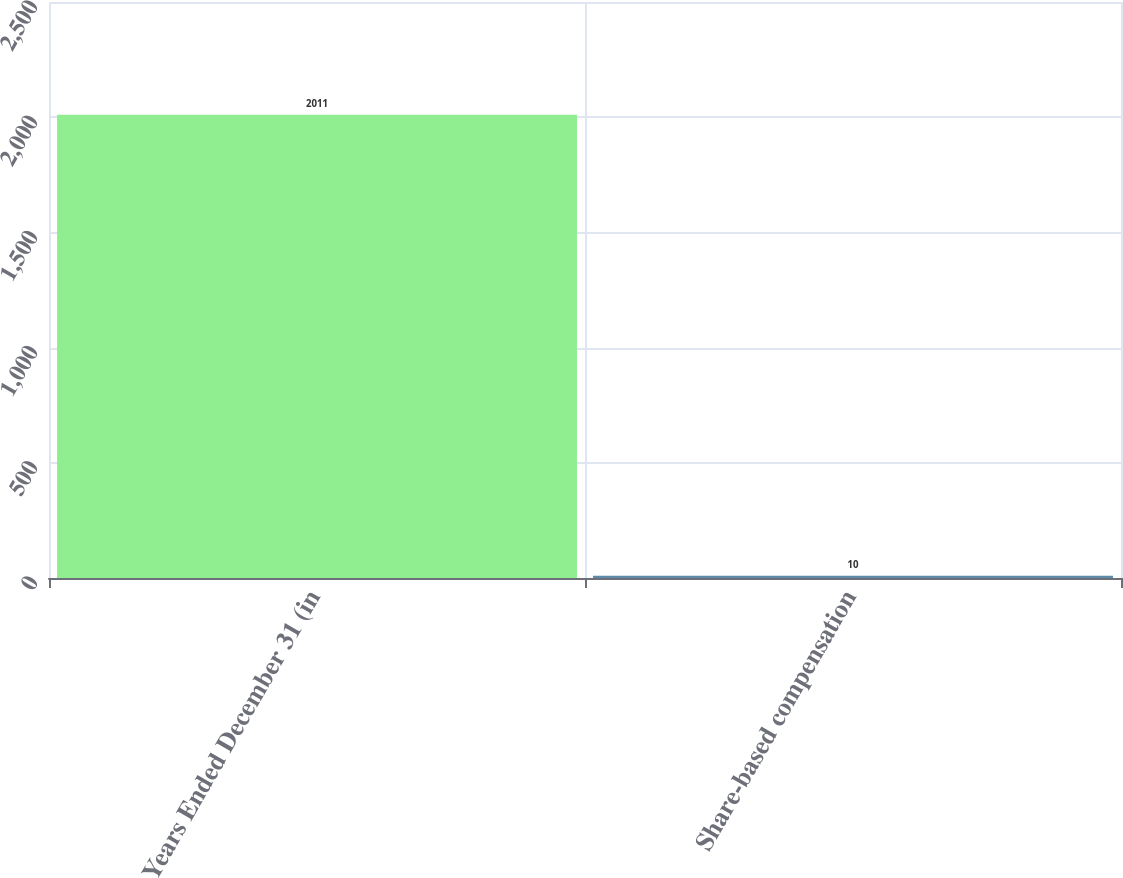Convert chart to OTSL. <chart><loc_0><loc_0><loc_500><loc_500><bar_chart><fcel>Years Ended December 31 (in<fcel>Share-based compensation<nl><fcel>2011<fcel>10<nl></chart> 